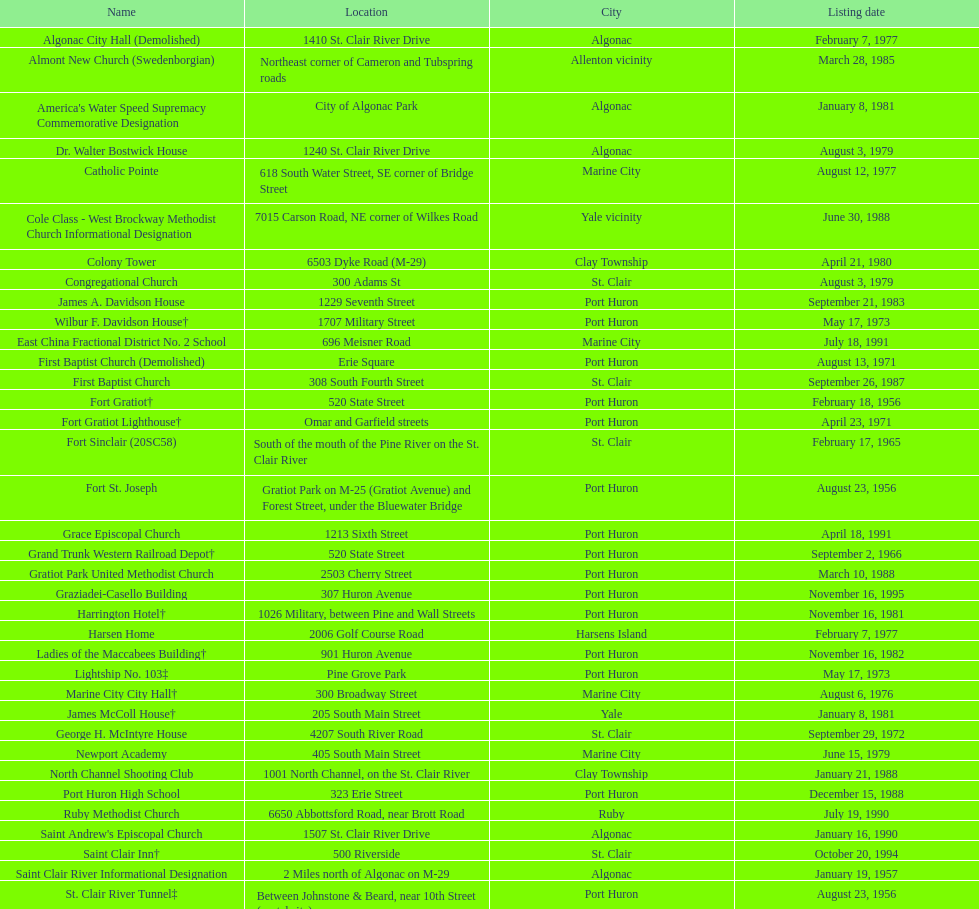Write the full table. {'header': ['Name', 'Location', 'City', 'Listing date'], 'rows': [['Algonac City Hall (Demolished)', '1410 St. Clair River Drive', 'Algonac', 'February 7, 1977'], ['Almont New Church (Swedenborgian)', 'Northeast corner of Cameron and Tubspring roads', 'Allenton vicinity', 'March 28, 1985'], ["America's Water Speed Supremacy Commemorative Designation", 'City of Algonac Park', 'Algonac', 'January 8, 1981'], ['Dr. Walter Bostwick House', '1240 St. Clair River Drive', 'Algonac', 'August 3, 1979'], ['Catholic Pointe', '618 South Water Street, SE corner of Bridge Street', 'Marine City', 'August 12, 1977'], ['Cole Class - West Brockway Methodist Church Informational Designation', '7015 Carson Road, NE corner of Wilkes Road', 'Yale vicinity', 'June 30, 1988'], ['Colony Tower', '6503 Dyke Road (M-29)', 'Clay Township', 'April 21, 1980'], ['Congregational Church', '300 Adams St', 'St. Clair', 'August 3, 1979'], ['James A. Davidson House', '1229 Seventh Street', 'Port Huron', 'September 21, 1983'], ['Wilbur F. Davidson House†', '1707 Military Street', 'Port Huron', 'May 17, 1973'], ['East China Fractional District No. 2 School', '696 Meisner Road', 'Marine City', 'July 18, 1991'], ['First Baptist Church (Demolished)', 'Erie Square', 'Port Huron', 'August 13, 1971'], ['First Baptist Church', '308 South Fourth Street', 'St. Clair', 'September 26, 1987'], ['Fort Gratiot†', '520 State Street', 'Port Huron', 'February 18, 1956'], ['Fort Gratiot Lighthouse†', 'Omar and Garfield streets', 'Port Huron', 'April 23, 1971'], ['Fort Sinclair (20SC58)', 'South of the mouth of the Pine River on the St. Clair River', 'St. Clair', 'February 17, 1965'], ['Fort St. Joseph', 'Gratiot Park on M-25 (Gratiot Avenue) and Forest Street, under the Bluewater Bridge', 'Port Huron', 'August 23, 1956'], ['Grace Episcopal Church', '1213 Sixth Street', 'Port Huron', 'April 18, 1991'], ['Grand Trunk Western Railroad Depot†', '520 State Street', 'Port Huron', 'September 2, 1966'], ['Gratiot Park United Methodist Church', '2503 Cherry Street', 'Port Huron', 'March 10, 1988'], ['Graziadei-Casello Building', '307 Huron Avenue', 'Port Huron', 'November 16, 1995'], ['Harrington Hotel†', '1026 Military, between Pine and Wall Streets', 'Port Huron', 'November 16, 1981'], ['Harsen Home', '2006 Golf Course Road', 'Harsens Island', 'February 7, 1977'], ['Ladies of the Maccabees Building†', '901 Huron Avenue', 'Port Huron', 'November 16, 1982'], ['Lightship No. 103‡', 'Pine Grove Park', 'Port Huron', 'May 17, 1973'], ['Marine City City Hall†', '300 Broadway Street', 'Marine City', 'August 6, 1976'], ['James McColl House†', '205 South Main Street', 'Yale', 'January 8, 1981'], ['George H. McIntyre House', '4207 South River Road', 'St. Clair', 'September 29, 1972'], ['Newport Academy', '405 South Main Street', 'Marine City', 'June 15, 1979'], ['North Channel Shooting Club', '1001 North Channel, on the St. Clair River', 'Clay Township', 'January 21, 1988'], ['Port Huron High School', '323 Erie Street', 'Port Huron', 'December 15, 1988'], ['Ruby Methodist Church', '6650 Abbottsford Road, near Brott Road', 'Ruby', 'July 19, 1990'], ["Saint Andrew's Episcopal Church", '1507 St. Clair River Drive', 'Algonac', 'January 16, 1990'], ['Saint Clair Inn†', '500 Riverside', 'St. Clair', 'October 20, 1994'], ['Saint Clair River Informational Designation', '2 Miles north of Algonac on M-29', 'Algonac', 'January 19, 1957'], ['St. Clair River Tunnel‡', 'Between Johnstone & Beard, near 10th Street (portal site)', 'Port Huron', 'August 23, 1956'], ['Saint Johannes Evangelische Kirche', '710 Pine Street, at Seventh Street', 'Port Huron', 'March 19, 1980'], ["Saint Mary's Catholic Church and Rectory", '415 North Sixth Street, between Vine and Orchard streets', 'St. Clair', 'September 25, 1985'], ['Jefferson Sheldon House', '807 Prospect Place', 'Port Huron', 'April 19, 1990'], ['Trinity Evangelical Lutheran Church', '1517 Tenth Street', 'Port Huron', 'August 29, 1996'], ['Wales Township Hall', '1372 Wales Center', 'Wales Township', 'July 18, 1996'], ['Ward-Holland House†', '433 North Main Street', 'Marine City', 'May 5, 1964'], ['E. C. Williams House', '2511 Tenth Avenue, between Hancock and Church streets', 'Port Huron', 'November 18, 1993'], ['C. H. Wills & Company', 'Chrysler Plant, 840 Huron Avenue', 'Marysville', 'June 23, 1983'], ["Woman's Benefit Association Building", '1338 Military Street', 'Port Huron', 'December 15, 1988']]} What is the count of properties on the list that have been destroyed? 2. 